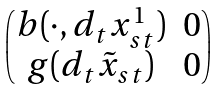Convert formula to latex. <formula><loc_0><loc_0><loc_500><loc_500>\begin{pmatrix} b ( \cdot , d _ { t } x _ { s t } ^ { 1 } ) & 0 \\ g ( d _ { t } \tilde { x } _ { s t } ) & 0 \end{pmatrix}</formula> 